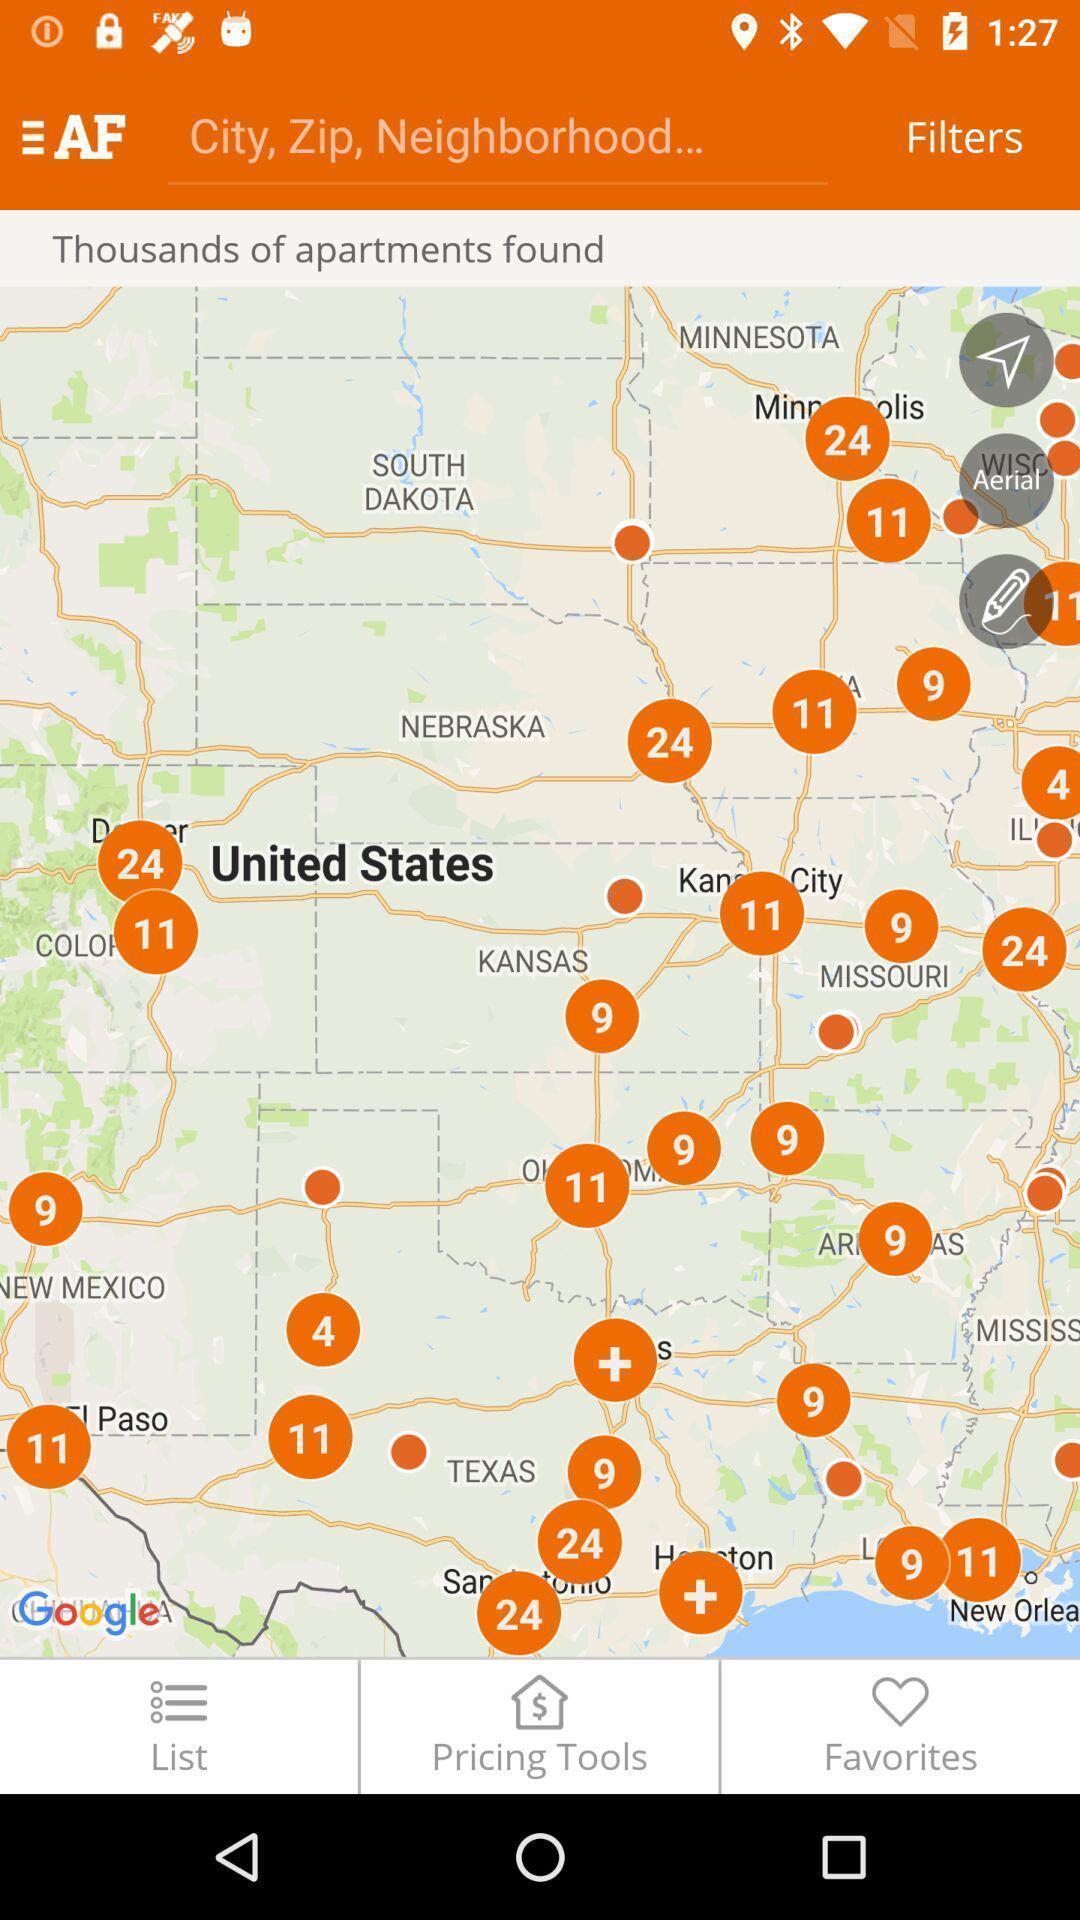What is the overall content of this screenshot? Screen showing map. 